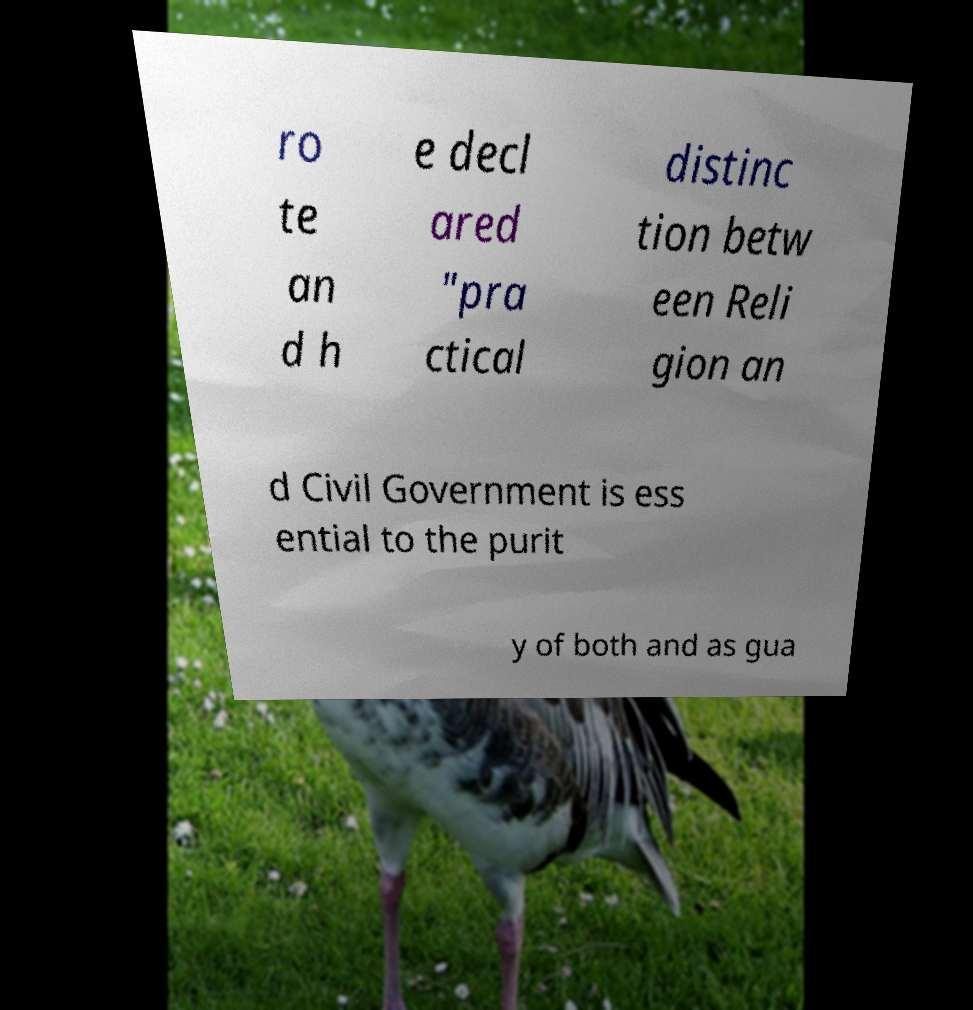For documentation purposes, I need the text within this image transcribed. Could you provide that? ro te an d h e decl ared "pra ctical distinc tion betw een Reli gion an d Civil Government is ess ential to the purit y of both and as gua 